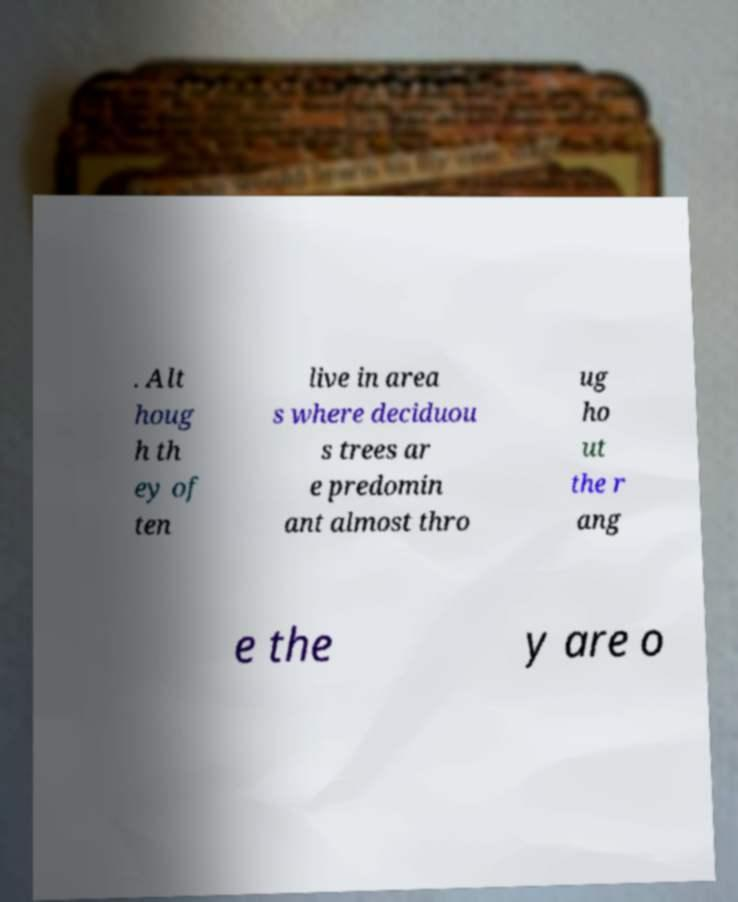Can you accurately transcribe the text from the provided image for me? . Alt houg h th ey of ten live in area s where deciduou s trees ar e predomin ant almost thro ug ho ut the r ang e the y are o 